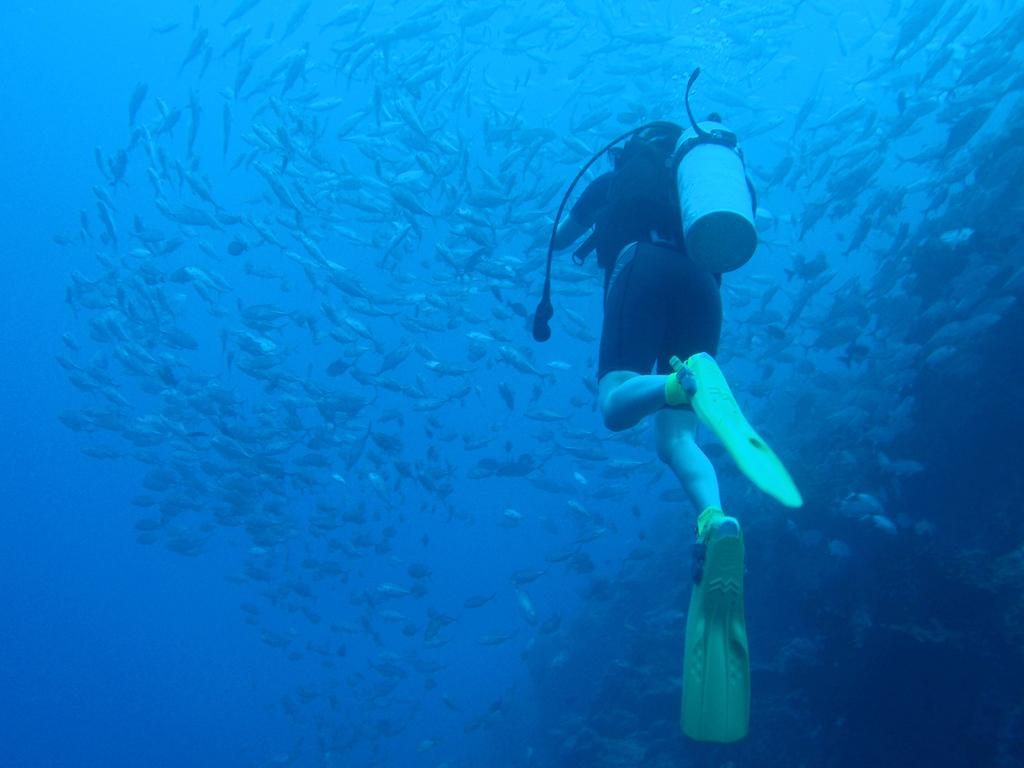What activity is the person in the image engaged in? The person in the image is doing scuba diving. What can be seen in the water around the scuba diver? There is a large school of fish in the water. What flavor of ice cream is the person eating while doing scuba diving in the image? There is no ice cream present in the image, and the person is not eating anything while doing scuba diving. 